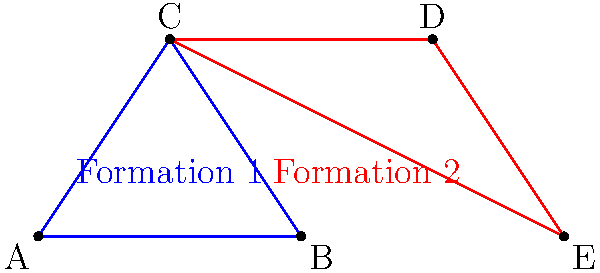In a football match, two team formations are represented by triangles ABC and CDE. If $\overline{AB} = 4$ units, $\overline{BC} = \sqrt{13}$ units, $\overline{CD} = 4$ units, and $\overline{DE} = \sqrt{13}$ units, are the two formations congruent? If so, state the congruence criterion used. Let's approach this step-by-step:

1) For two triangles to be congruent, they must have three corresponding parts equal (sides or angles).

2) We're given that:
   $\overline{AB} = 4$ units
   $\overline{BC} = \sqrt{13}$ units
   $\overline{CD} = 4$ units
   $\overline{DE} = \sqrt{13}$ units

3) We can see that:
   $\overline{AB} = \overline{CD} = 4$ units
   $\overline{BC} = \overline{DE} = \sqrt{13}$ units

4) For the third side, we need to prove that $\overline{AC} = \overline{CE}$. We're not given this information directly, but we can infer it:

   - Triangle ABC and CDE share side $\overline{BC}$ and $\overline{DE}$ respectively, which are equal.
   - The other two sides of each triangle are equal to the corresponding sides of the other triangle.
   - This means that $\overline{AC}$ must equal $\overline{CE}$ for the triangles to have the same shape and size.

5) Therefore, we have three pairs of corresponding sides that are equal:
   $\overline{AB} = \overline{CD}$
   $\overline{BC} = \overline{DE}$
   $\overline{AC} = \overline{CE}$

6) This satisfies the Side-Side-Side (SSS) congruence criterion, which states that if three sides of one triangle are equal to three sides of another triangle, the triangles are congruent.

Thus, the two formations represented by triangles ABC and CDE are congruent by the SSS criterion.
Answer: Yes, SSS criterion 